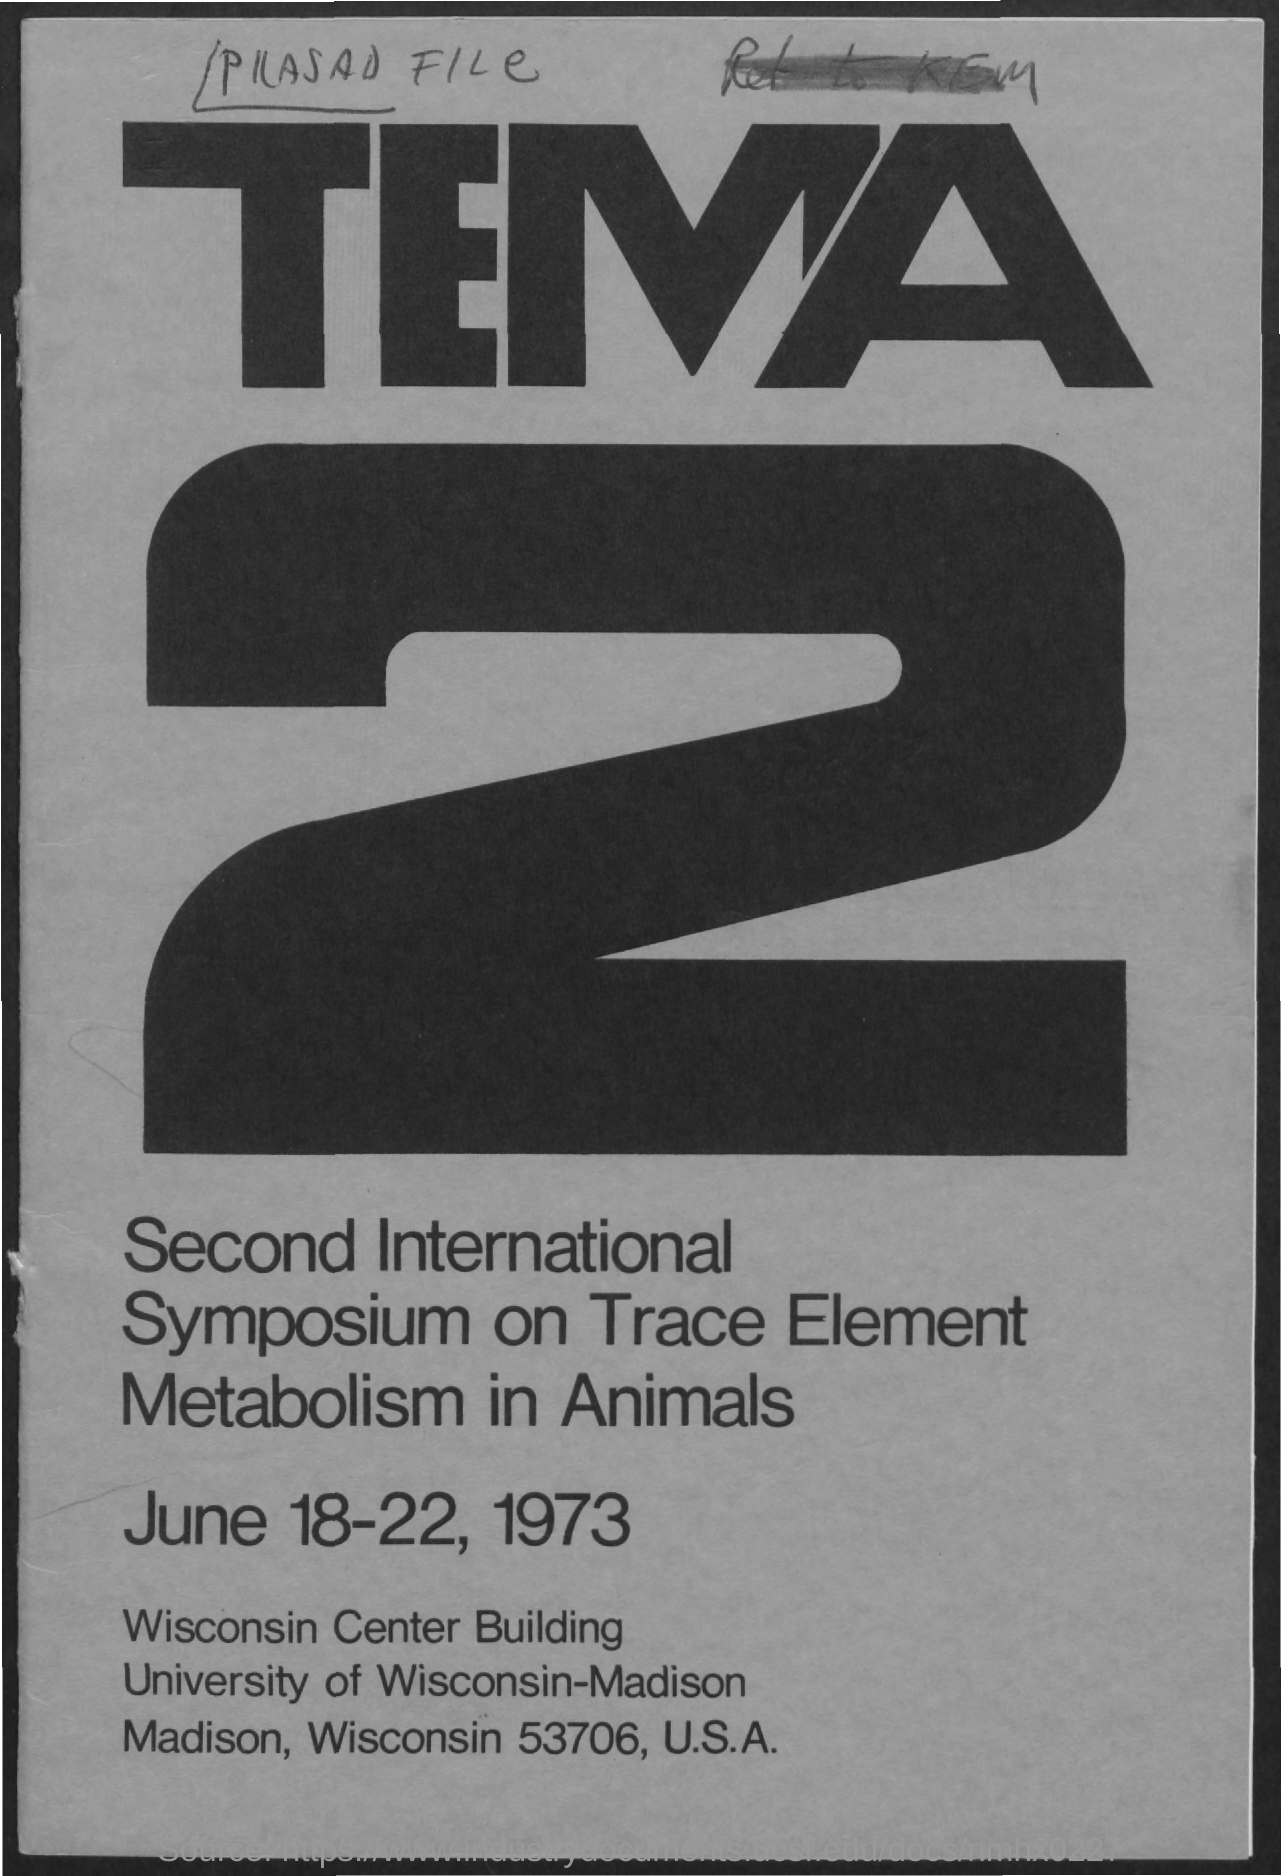Draw attention to some important aspects in this diagram. The Second International Symposium on Trace Element Metabolism in Animals was held from June 18-22, 1973. 